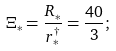Convert formula to latex. <formula><loc_0><loc_0><loc_500><loc_500>\Xi _ { \ast } = \frac { R _ { \ast } } { r _ { \ast } ^ { \dagger } } = \frac { 4 0 } 3 ;</formula> 